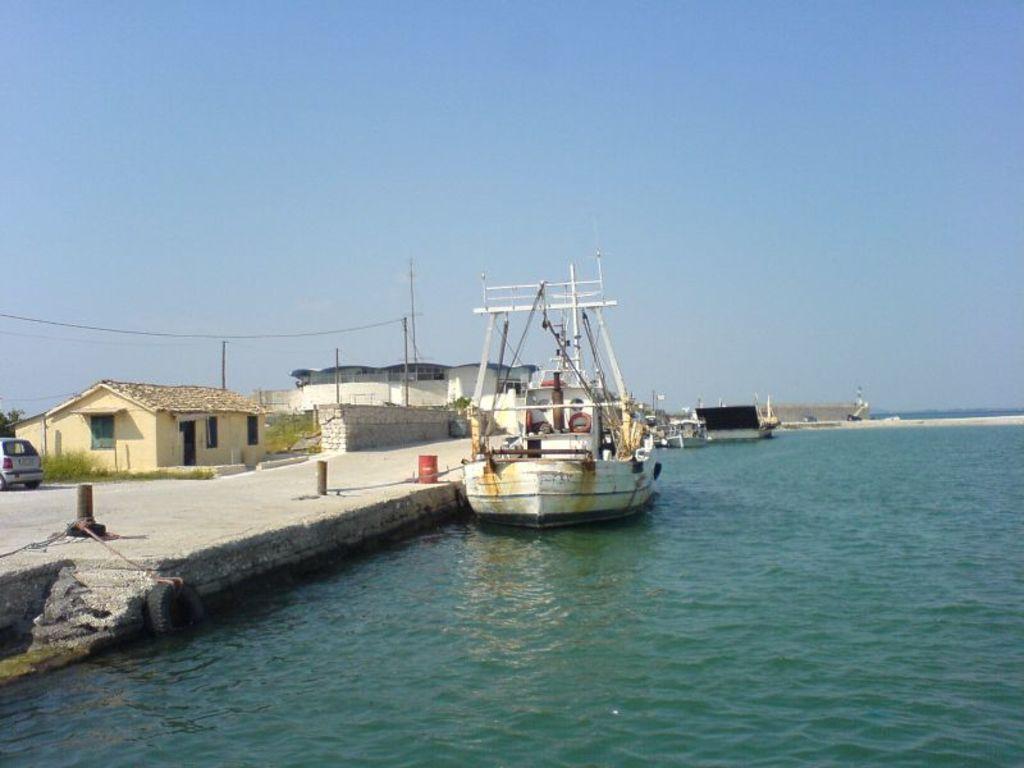Can you describe this image briefly? In this image there is water on the right corner. And there is water at the bottom. There is a house, a vehicle, there is grass, there are trees on the left corner. There is a boat, there are poles, there is a building. And there is sky at the top. 